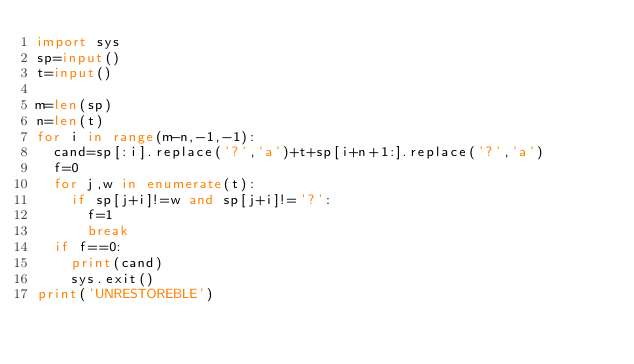<code> <loc_0><loc_0><loc_500><loc_500><_Python_>import sys
sp=input()
t=input()

m=len(sp)
n=len(t)
for i in range(m-n,-1,-1):
  cand=sp[:i].replace('?','a')+t+sp[i+n+1:].replace('?','a')
  f=0
  for j,w in enumerate(t):
    if sp[j+i]!=w and sp[j+i]!='?':
      f=1
      break
  if f==0:
    print(cand)
    sys.exit()
print('UNRESTOREBLE')
</code> 